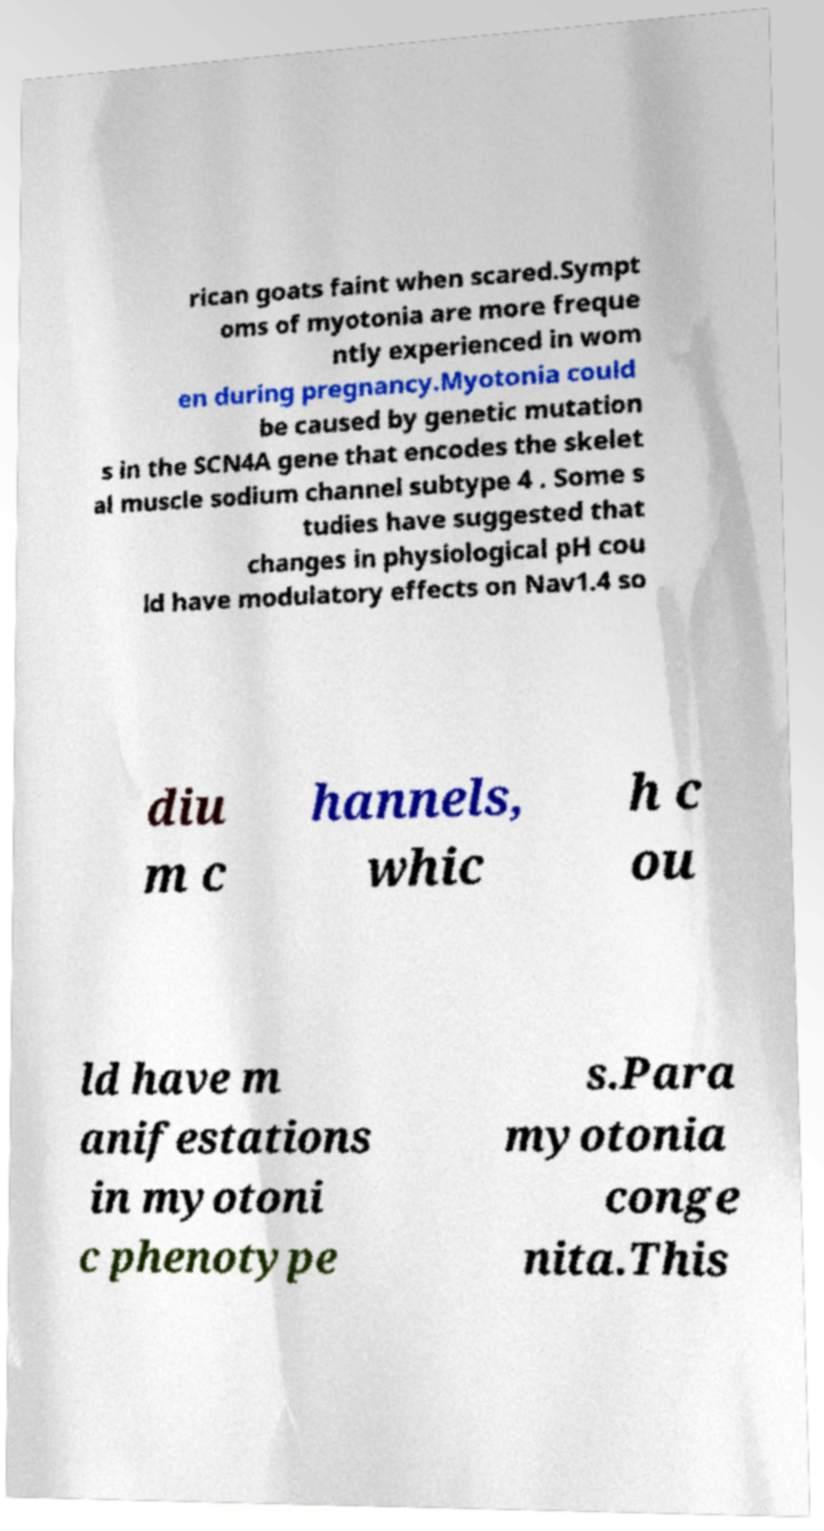I need the written content from this picture converted into text. Can you do that? rican goats faint when scared.Sympt oms of myotonia are more freque ntly experienced in wom en during pregnancy.Myotonia could be caused by genetic mutation s in the SCN4A gene that encodes the skelet al muscle sodium channel subtype 4 . Some s tudies have suggested that changes in physiological pH cou ld have modulatory effects on Nav1.4 so diu m c hannels, whic h c ou ld have m anifestations in myotoni c phenotype s.Para myotonia conge nita.This 